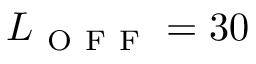<formula> <loc_0><loc_0><loc_500><loc_500>L _ { O F F } = 3 0</formula> 